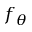Convert formula to latex. <formula><loc_0><loc_0><loc_500><loc_500>f _ { \theta }</formula> 